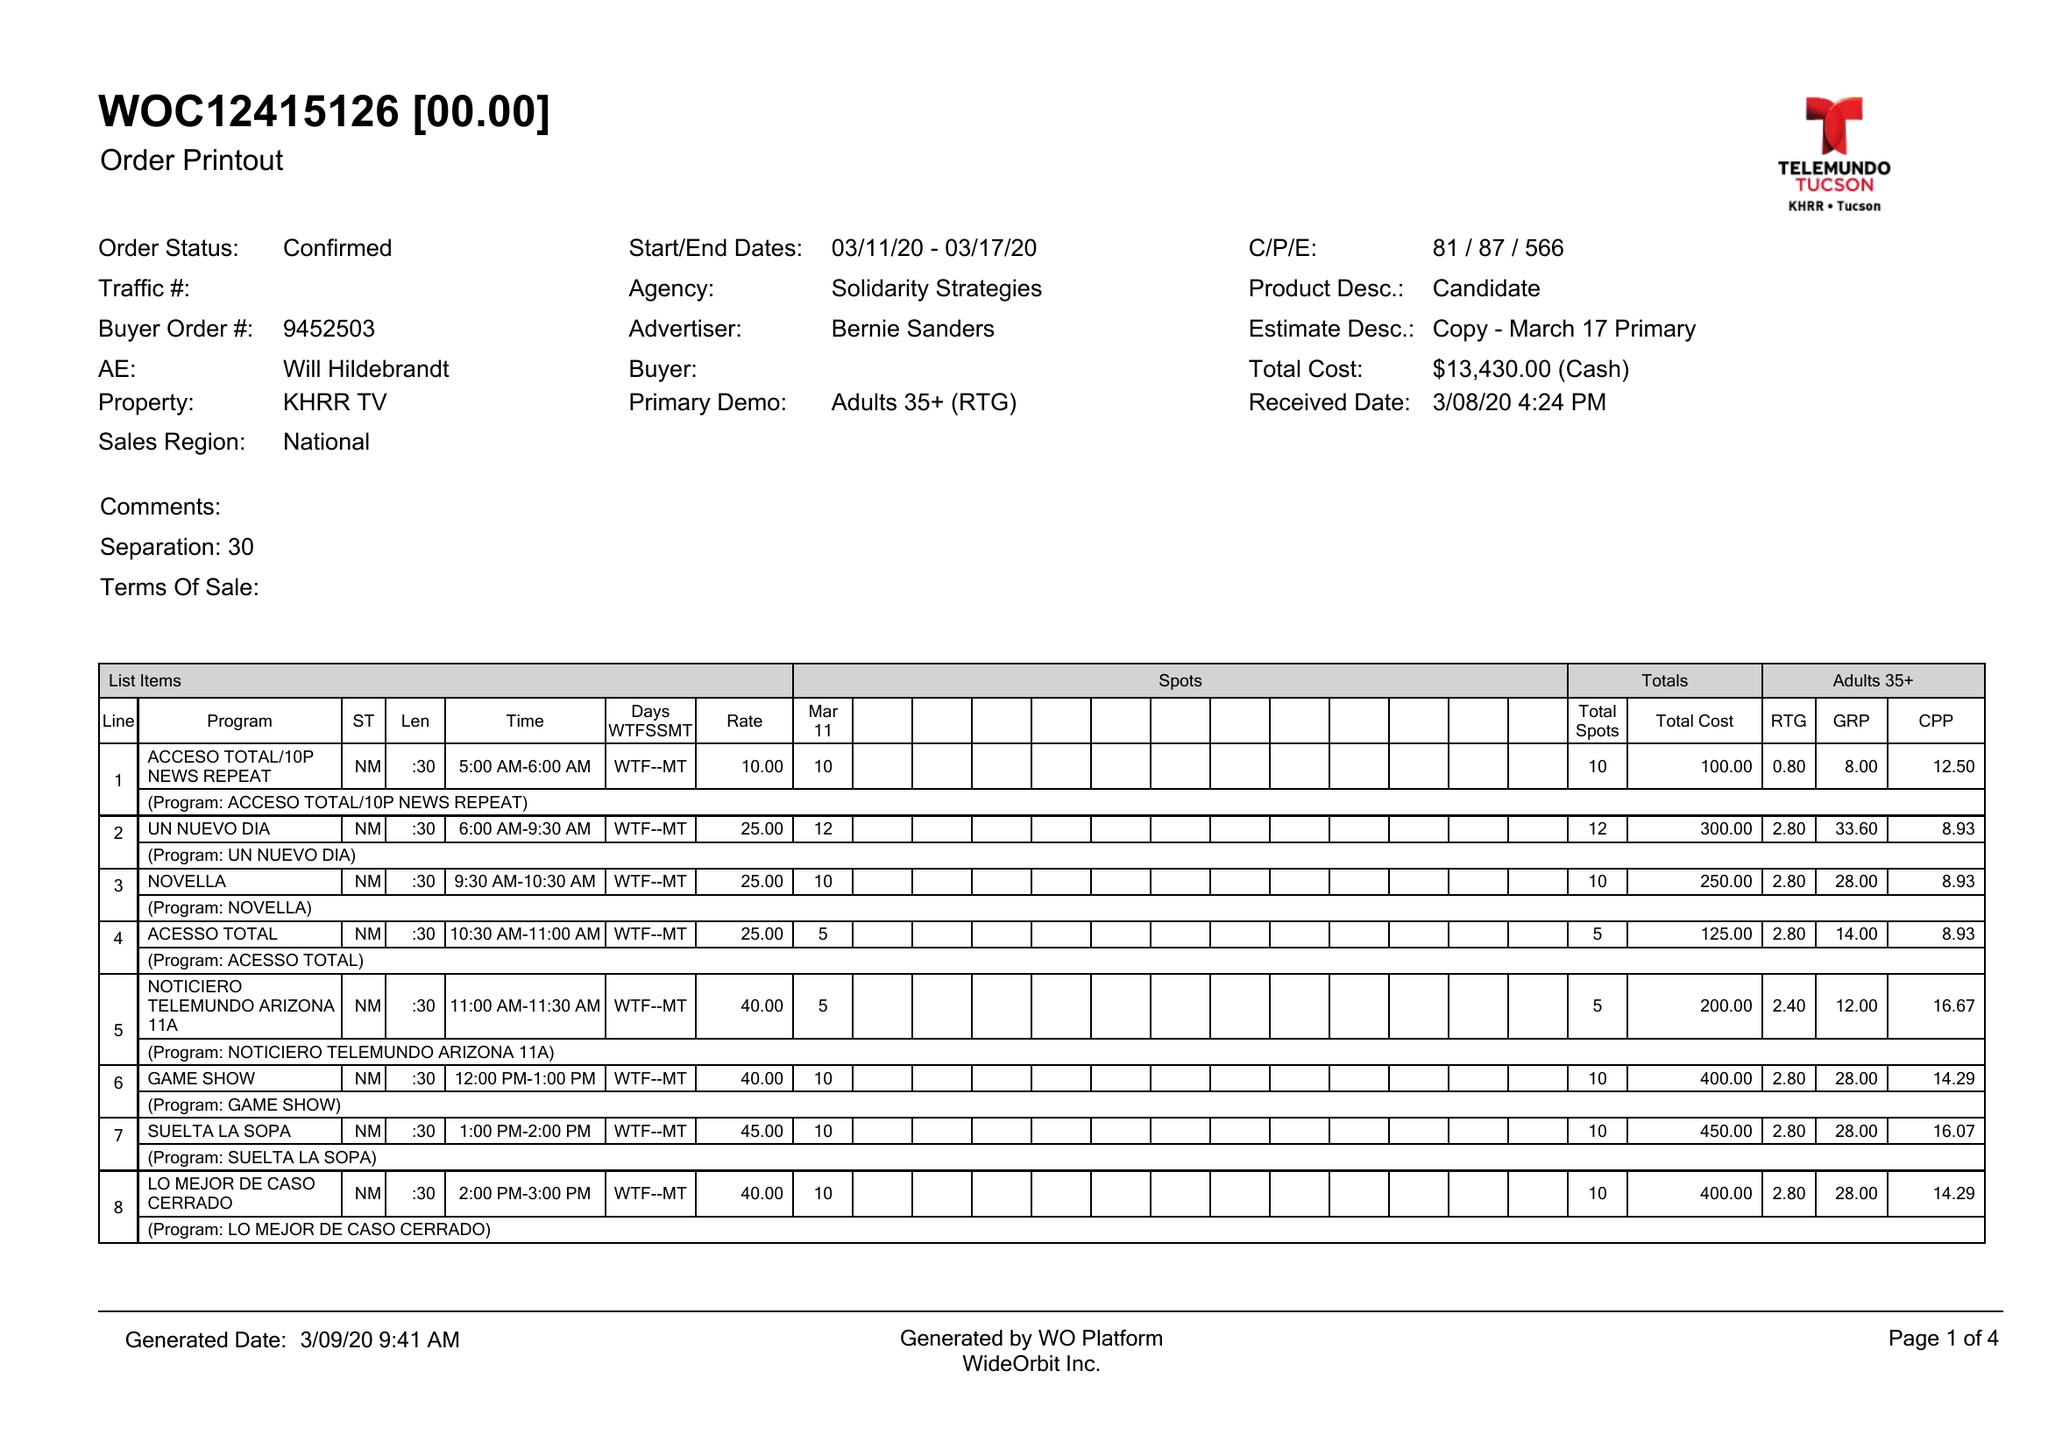What is the value for the advertiser?
Answer the question using a single word or phrase. BERNIE SANDERS 